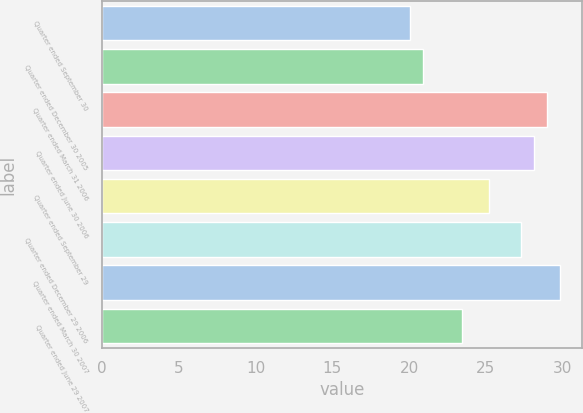Convert chart. <chart><loc_0><loc_0><loc_500><loc_500><bar_chart><fcel>Quarter ended September 30<fcel>Quarter ended December 30 2005<fcel>Quarter ended March 31 2006<fcel>Quarter ended June 30 2006<fcel>Quarter ended September 29<fcel>Quarter ended December 29 2006<fcel>Quarter ended March 30 2007<fcel>Quarter ended June 29 2007<nl><fcel>20.08<fcel>20.92<fcel>28.95<fcel>28.11<fcel>25.2<fcel>27.27<fcel>29.79<fcel>23.47<nl></chart> 